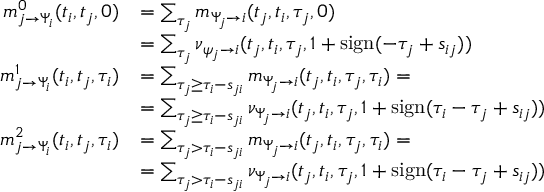Convert formula to latex. <formula><loc_0><loc_0><loc_500><loc_500>\begin{array} { r l } { m _ { j \to \Psi _ { i } } ^ { 0 } ( t _ { i } , t _ { j } , 0 ) } & { = \sum _ { \tau _ { j } } m _ { \Psi _ { j } \to i } ( t _ { j } , t _ { i } , \tau _ { j } , 0 ) } \\ & { = \sum _ { \tau _ { j } } \nu _ { \psi _ { j } \to i } ( t _ { j } , t _ { i } , \tau _ { j } , 1 + s i g n ( - \tau _ { j } + s _ { i j } ) ) } \\ { m _ { j \to \Psi _ { i } } ^ { 1 } ( t _ { i } , t _ { j } , \tau _ { i } ) } & { = \sum _ { \tau _ { j } \geq \tau _ { i } - s _ { j i } } m _ { \Psi _ { j } \to i } ( t _ { j } , t _ { i } , \tau _ { j } , \tau _ { i } ) = } \\ & { = \sum _ { \tau _ { j } \geq \tau _ { i } - s _ { j i } } \nu _ { \Psi _ { j } \to i } ( t _ { j } , t _ { i } , \tau _ { j } , 1 + s i g n ( \tau _ { i } - \tau _ { j } + s _ { i j } ) ) } \\ { m _ { j \to \Psi _ { i } } ^ { 2 } ( t _ { i } , t _ { j } , \tau _ { i } ) } & { = \sum _ { \tau _ { j } > \tau _ { i } - s _ { j i } } m _ { \Psi _ { j } \to i } ( t _ { j } , t _ { i } , \tau _ { j } , \tau _ { i } ) = } \\ & { = \sum _ { \tau _ { j } > \tau _ { i } - s _ { j i } } \nu _ { \Psi _ { j } \to i } ( t _ { j } , t _ { i } , \tau _ { j } , 1 + s i g n ( \tau _ { i } - \tau _ { j } + s _ { i j } ) ) } \end{array}</formula> 